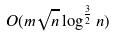Convert formula to latex. <formula><loc_0><loc_0><loc_500><loc_500>O ( m \sqrt { n } \log ^ { \frac { 3 } { 2 } } n )</formula> 